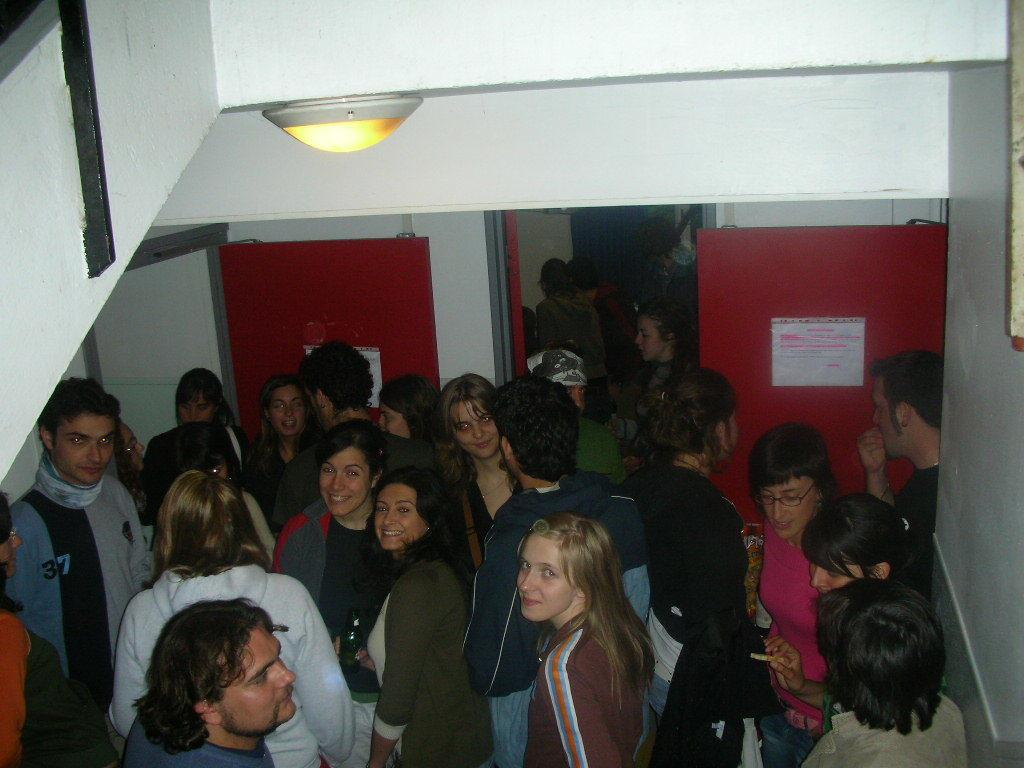What is the main subject of the image? There is a group of people standing in the center of the image. What objects are present in the middle of the image? Boards and a door are visible in the middle of the image. What structures are present at the top of the image? A roof and a light are present at the top of the image. What type of root can be seen growing from the door in the image? There is no root growing from the door in the image; only a door, boards, and a group of people are present. What is the opinion of the people in the image about the boards? The image does not provide any information about the opinions of the people regarding the boards. 